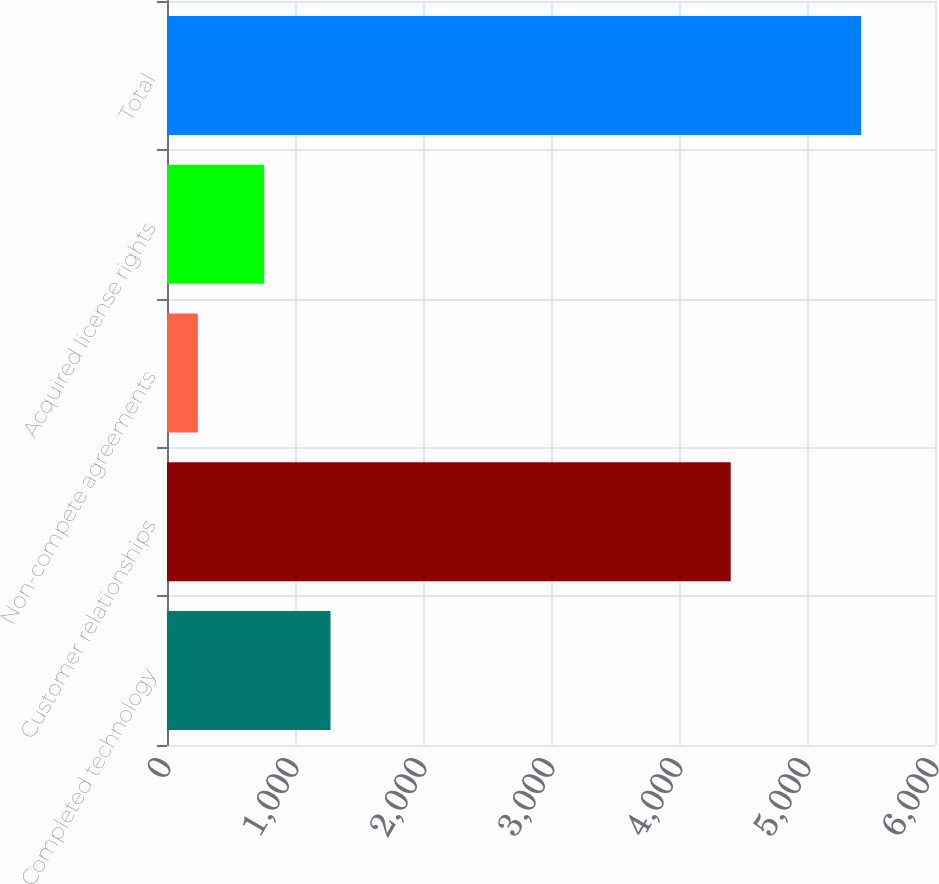<chart> <loc_0><loc_0><loc_500><loc_500><bar_chart><fcel>Completed technology<fcel>Customer relationships<fcel>Non-compete agreements<fcel>Acquired license rights<fcel>Total<nl><fcel>1277.4<fcel>4404<fcel>241<fcel>759.2<fcel>5423<nl></chart> 